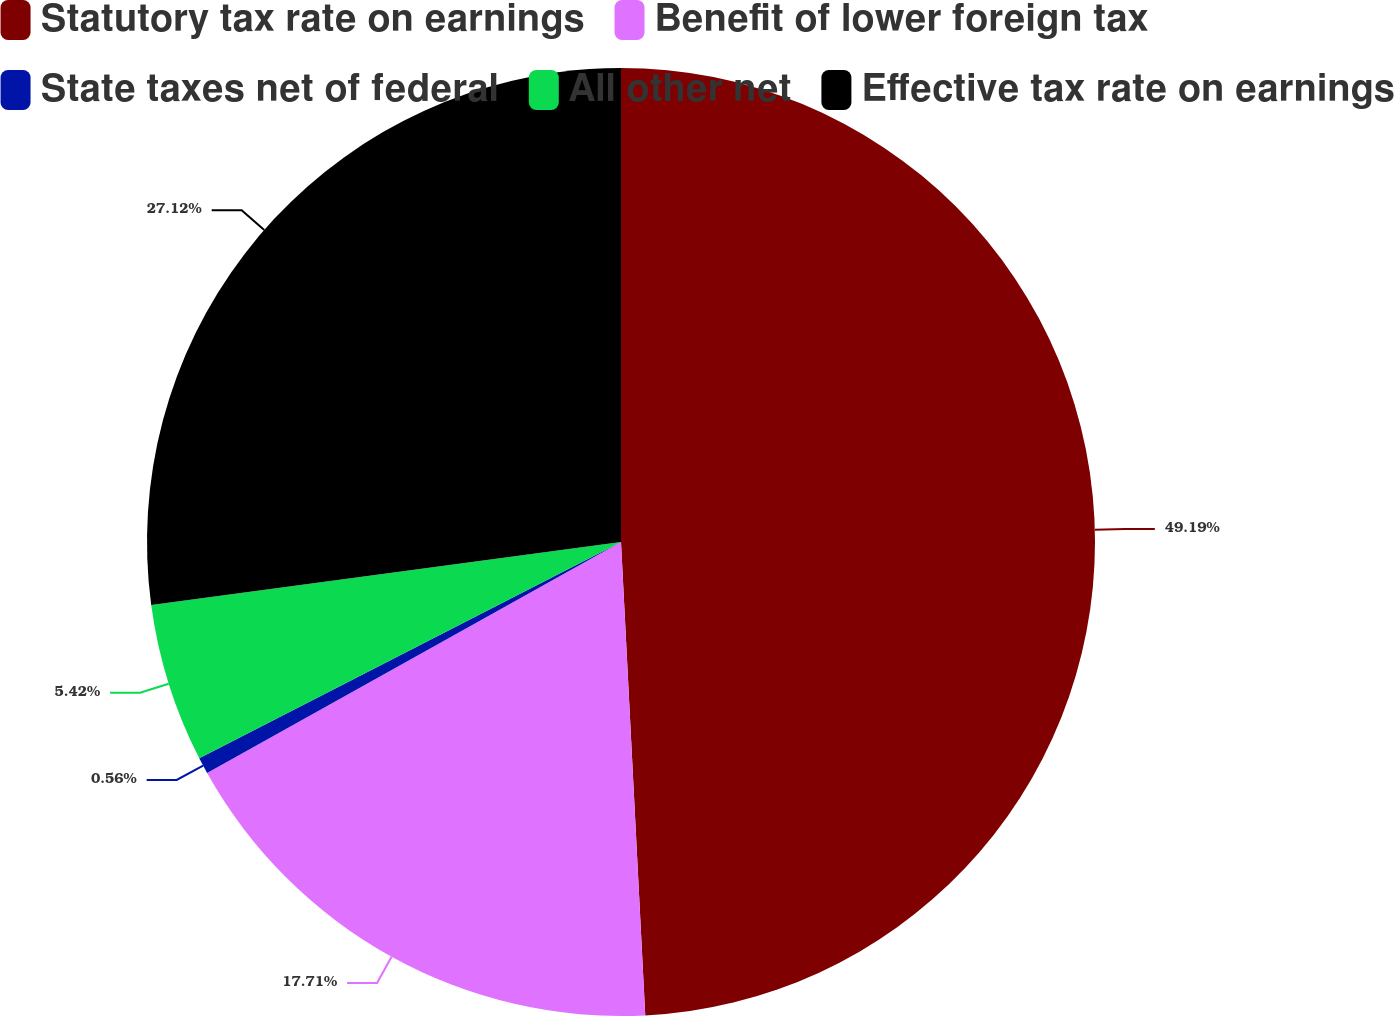<chart> <loc_0><loc_0><loc_500><loc_500><pie_chart><fcel>Statutory tax rate on earnings<fcel>Benefit of lower foreign tax<fcel>State taxes net of federal<fcel>All other net<fcel>Effective tax rate on earnings<nl><fcel>49.18%<fcel>17.71%<fcel>0.56%<fcel>5.42%<fcel>27.12%<nl></chart> 